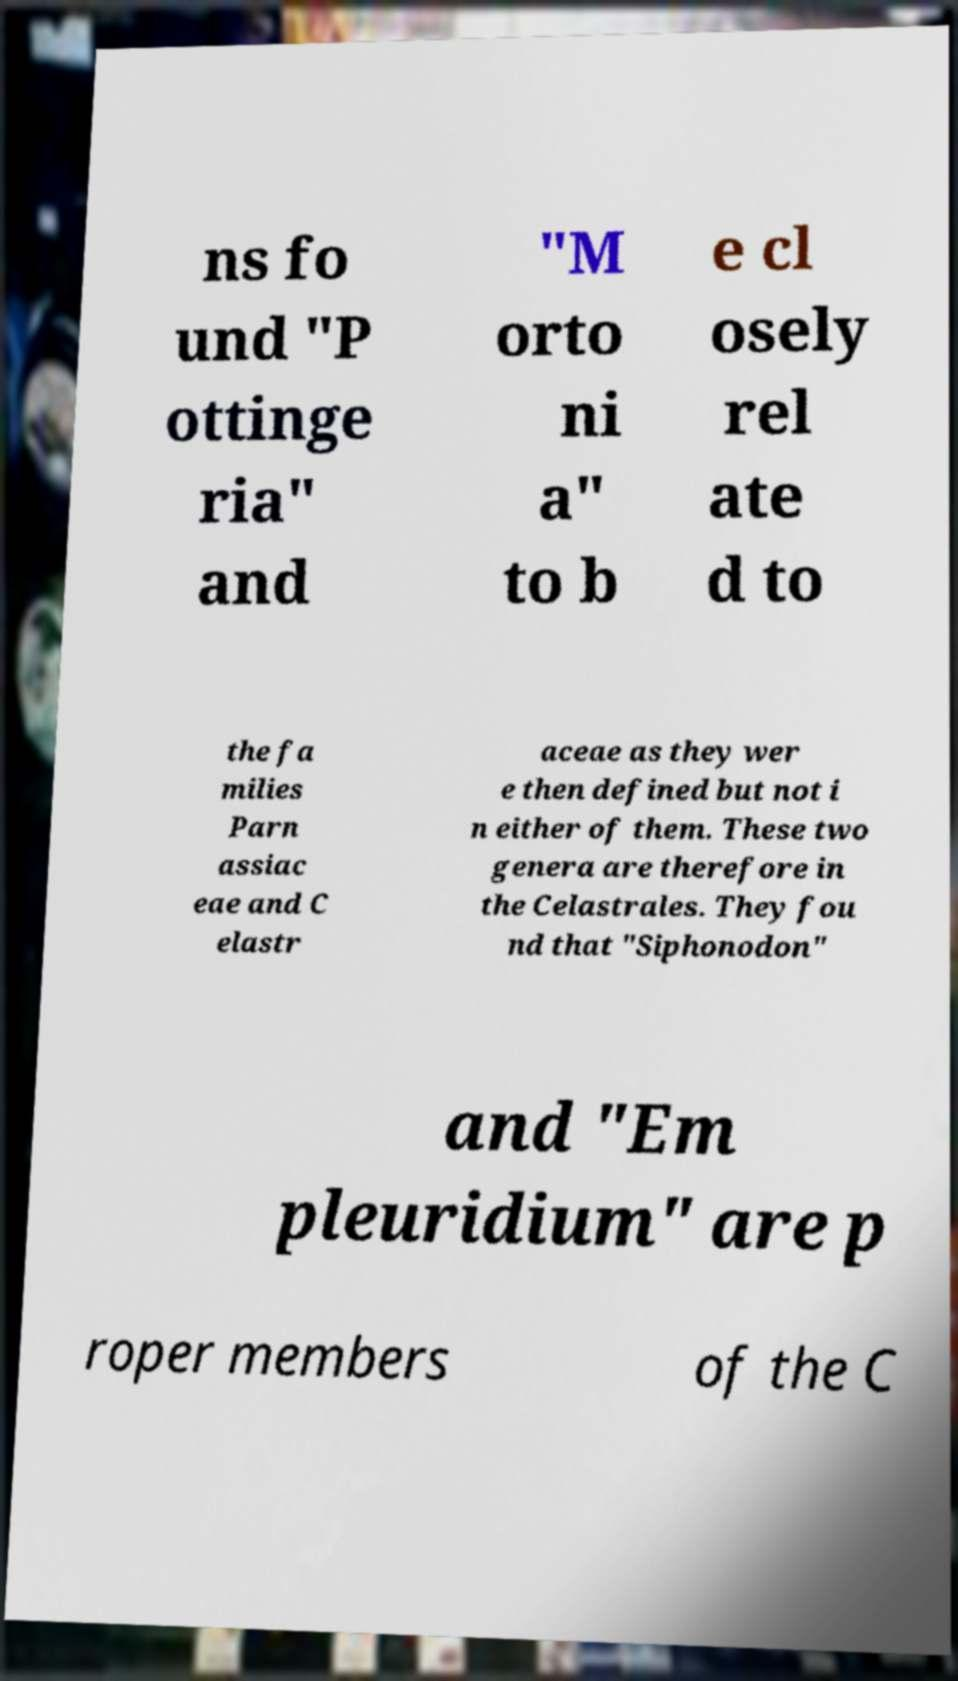For documentation purposes, I need the text within this image transcribed. Could you provide that? ns fo und "P ottinge ria" and "M orto ni a" to b e cl osely rel ate d to the fa milies Parn assiac eae and C elastr aceae as they wer e then defined but not i n either of them. These two genera are therefore in the Celastrales. They fou nd that "Siphonodon" and "Em pleuridium" are p roper members of the C 